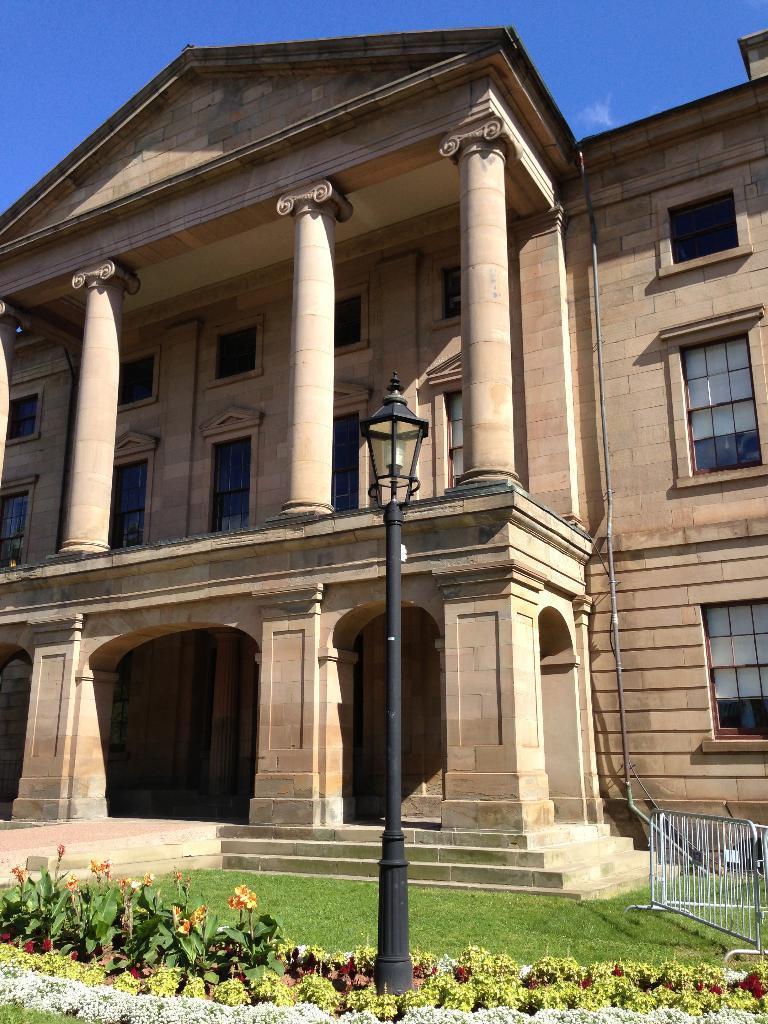How would you summarize this image in a sentence or two? This image consists of flowering plants, grass, fence, pole, building, windows and the sky. This image taken, maybe during a day. 